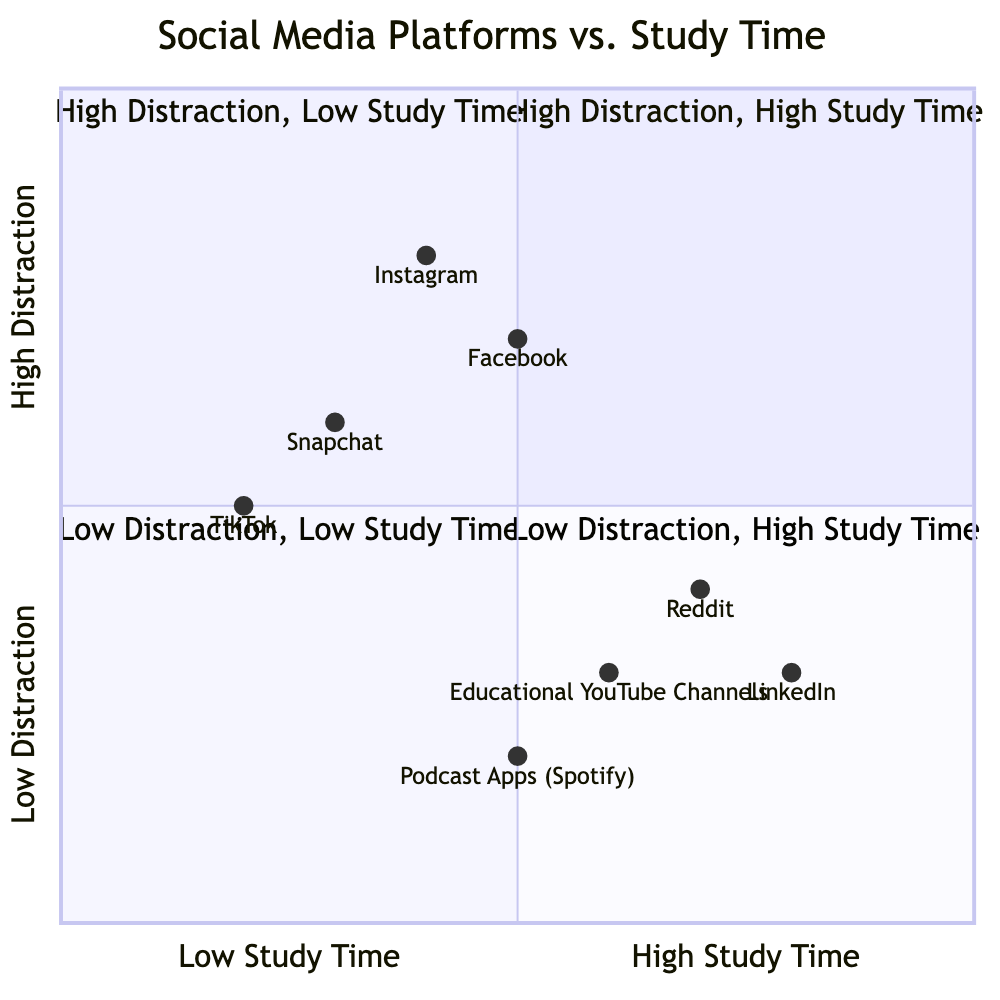What social media platform represents low study time and high distraction? According to the quadrant chart, TikTok and Snapchat are placed in the 'Low Study Time' category, while Instagram and Facebook are in the 'High Distraction' category. The platform that fits both criteria (low study time and high distraction) is Instagram.
Answer: Instagram Which social media platform has the highest study time? Analyzing the quadrant chart, LinkedIn and Reddit are associated with 'High Study Time.' Among these, LinkedIn is located higher on the quadrant, indicating it has the highest study time.
Answer: LinkedIn How many social media platforms are classified as low distraction? The diagram lists Podcast Apps (Spotify) and Educational YouTube Channels in the 'Low Distraction' category. Therefore, there are two platforms that fall into this classification.
Answer: 2 Which platform shows the highest distraction level along with the lowest study time? Instagram is positioned in the 'High Distraction' area and is also noted as one of the platforms that corresponds to 'Low Study Time.' Thus, it indicates the maximum distraction level with minimal study time.
Answer: Instagram What is the relationship between TikTok and Snapchat in terms of study time? Both TikTok and Snapchat are categorized under 'Low Study Time' in the quadrant chart, indicating that they have relatively similar levels of impact on study time.
Answer: Similar What is the study effectiveness of Podcast Apps (Spotify)? The quadrant chart places Podcast Apps (Spotify) in the 'Low Distraction' and 'High Study Time' areas. This indicates a positive relationship between the platform and effective study time usage.
Answer: High Which quadrant contains platforms favored for low distraction but is associated with low study time? Referring to the diagram, the 'Low Distraction, Low Study Time' quadrant includes Podcast Apps (Spotify) and Educational YouTube Channels, making it the area of interest.
Answer: Quadrant 3 What can be inferred about the distraction levels of Facebook compared to LinkedIn? Facebook is positioned in the 'High Distraction' area, while LinkedIn is in the 'Low Distraction' zone but associated with high study time. This indicates that Facebook tends to be more distracting than LinkedIn when studying.
Answer: More distracting 